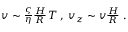Convert formula to latex. <formula><loc_0><loc_0><loc_500><loc_500>\begin{array} { r } { v \sim \frac { \varsigma } { \eta } \frac { H } { R } \, T \, , \, v _ { z } \sim v \frac { H } { R } \ . \ } \end{array}</formula> 